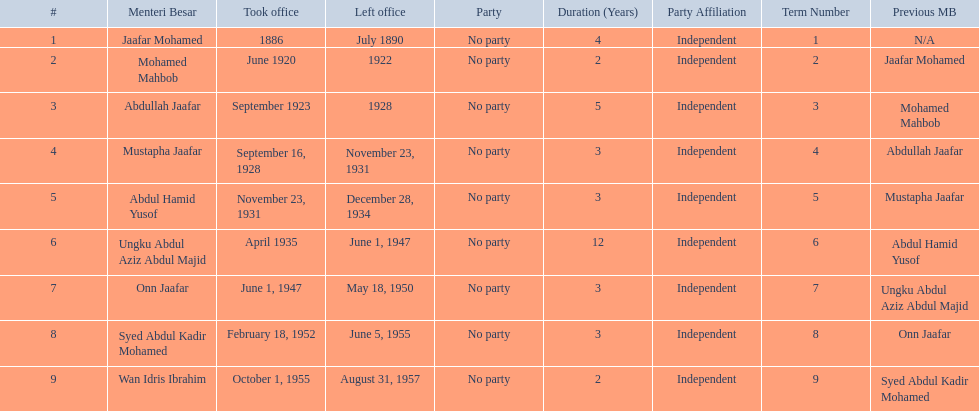Who was in office previous to abdullah jaafar? Mohamed Mahbob. 